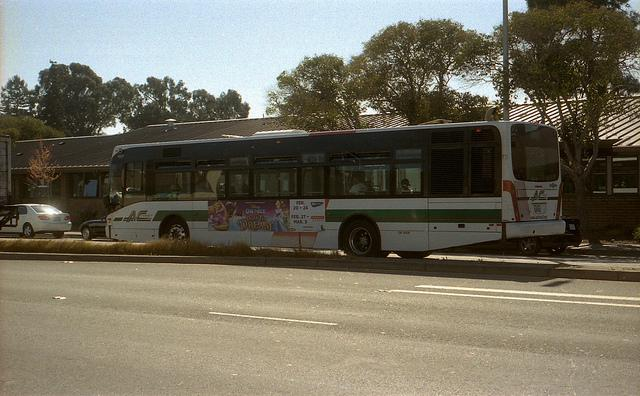What is the bus driving in? Please explain your reasoning. hov lane. The bus is in the hov lane. 